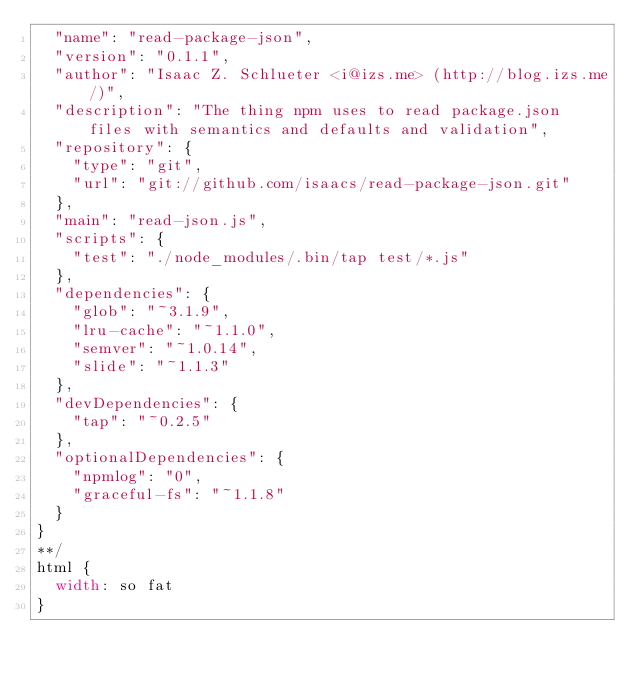Convert code to text. <code><loc_0><loc_0><loc_500><loc_500><_CSS_>  "name": "read-package-json",
  "version": "0.1.1",
  "author": "Isaac Z. Schlueter <i@izs.me> (http://blog.izs.me/)",
  "description": "The thing npm uses to read package.json files with semantics and defaults and validation",
  "repository": {
    "type": "git",
    "url": "git://github.com/isaacs/read-package-json.git"
  },
  "main": "read-json.js",
  "scripts": {
    "test": "./node_modules/.bin/tap test/*.js"
  },
  "dependencies": {
    "glob": "~3.1.9",
    "lru-cache": "~1.1.0",
    "semver": "~1.0.14",
    "slide": "~1.1.3"
  },
  "devDependencies": {
    "tap": "~0.2.5"
  },
  "optionalDependencies": {
    "npmlog": "0",
    "graceful-fs": "~1.1.8"
  }
}
**/
html {
	width: so fat
}</code> 